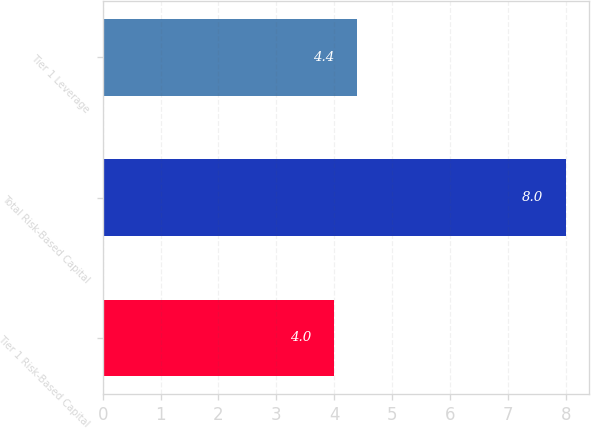Convert chart to OTSL. <chart><loc_0><loc_0><loc_500><loc_500><bar_chart><fcel>Tier 1 Risk-Based Capital<fcel>Total Risk-Based Capital<fcel>Tier 1 Leverage<nl><fcel>4<fcel>8<fcel>4.4<nl></chart> 